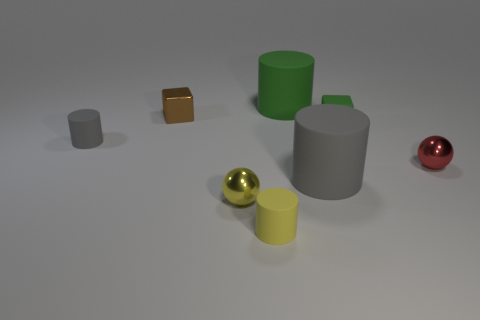Add 1 large gray objects. How many objects exist? 9 Subtract all large green matte cylinders. How many cylinders are left? 3 Subtract all yellow balls. How many balls are left? 1 Subtract all cubes. How many objects are left? 6 Subtract 3 cylinders. How many cylinders are left? 1 Subtract all cyan cylinders. How many red spheres are left? 1 Add 7 small green balls. How many small green balls exist? 7 Subtract 0 purple cylinders. How many objects are left? 8 Subtract all yellow blocks. Subtract all purple cylinders. How many blocks are left? 2 Subtract all large rubber cylinders. Subtract all green things. How many objects are left? 4 